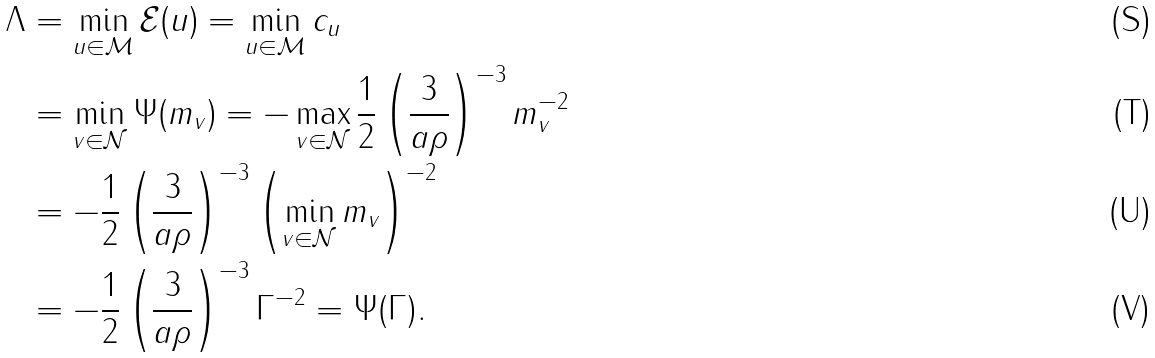Convert formula to latex. <formula><loc_0><loc_0><loc_500><loc_500>\Lambda & = \min _ { u \in { \mathcal { M } } } { \mathcal { E } } ( u ) = \min _ { u \in { \mathcal { M } } } c _ { u } \\ & = \min _ { v \in { \mathcal { N } } } \Psi ( m _ { v } ) = - \max _ { v \in { \mathcal { N } } } \frac { 1 } { 2 } \left ( \frac { 3 } { a \rho } \right ) ^ { - 3 } m _ { v } ^ { - 2 } \\ & = - \frac { 1 } { 2 } \left ( \frac { 3 } { a \rho } \right ) ^ { - 3 } \left ( \min _ { v \in { \mathcal { N } } } m _ { v } \right ) ^ { - 2 } \\ & = - \frac { 1 } { 2 } \left ( \frac { 3 } { a \rho } \right ) ^ { - 3 } \Gamma ^ { - 2 } = \Psi ( \Gamma ) .</formula> 